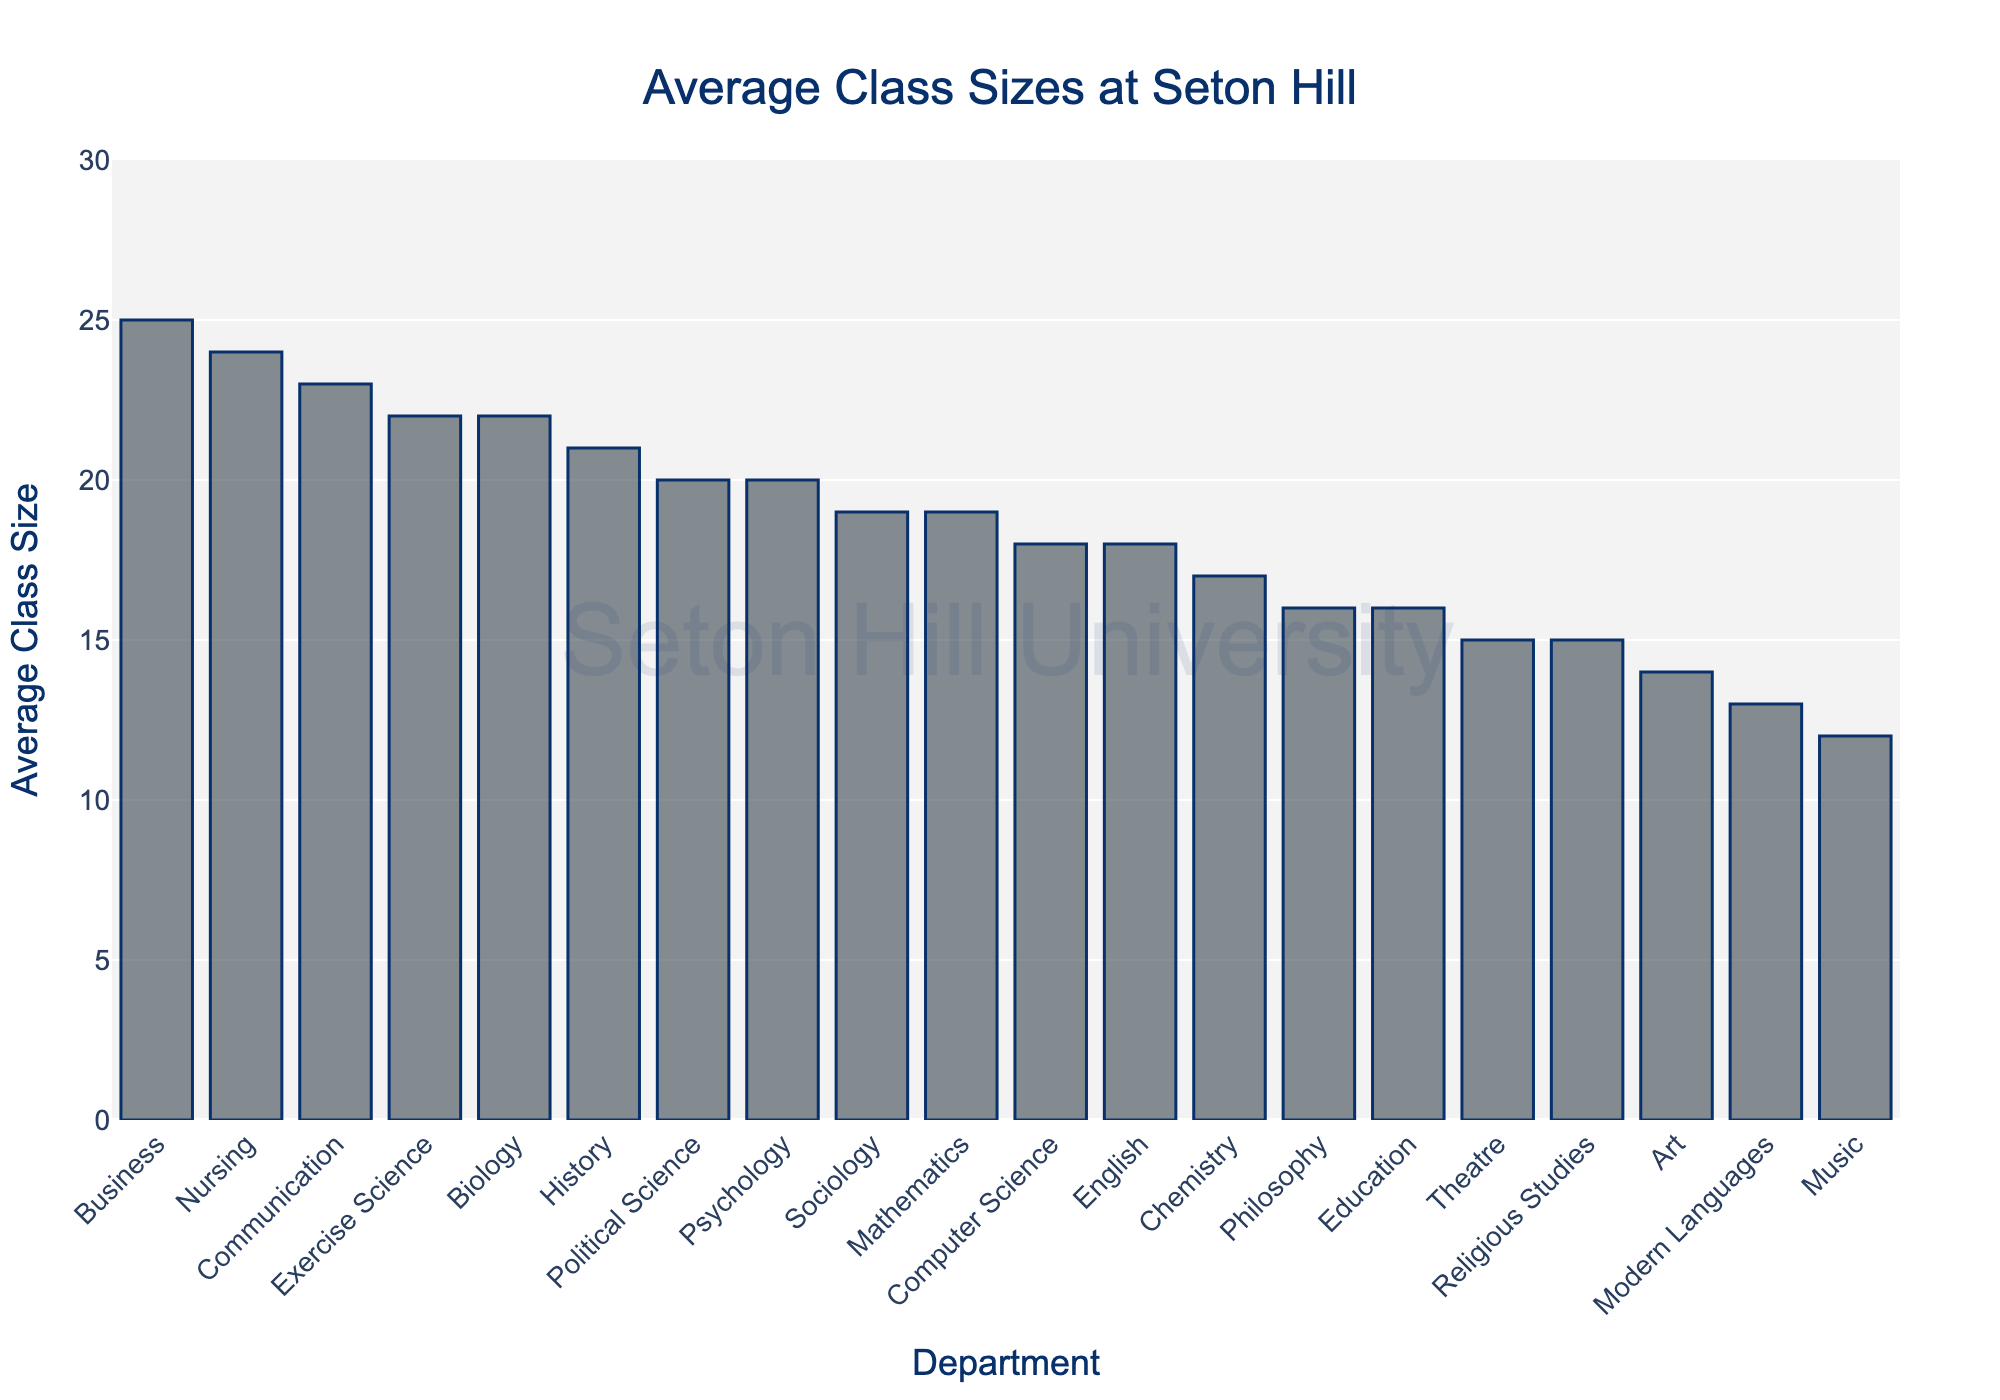Which department has the largest average class size? Visual inspection shows that the Business department has the highest bar, indicating the largest average class size of 25.
Answer: Business Which department has the smallest average class size? The Music department has the shortest bar, indicating the smallest average class size of 12.
Answer: Music What is the difference between the largest and smallest average class sizes? The largest average class size is in Business (25), and the smallest is in Music (12). Subtract 12 from 25 to find the difference: 25 - 12 = 13.
Answer: 13 Are there any departments with the same average class size? Yes, the Psychology and Political Science departments both have an average class size of 20.
Answer: Yes How does the average class size of the Education department compare to that of the Mathematics department? The Education department has an average class size of 16, while the Mathematics department has an average class size of 19, meaning Education's size is smaller.
Answer: Education smaller What is the combined average class size of the Art and Theatre departments? Art has an average class size of 14 and Theatre has 15. Adding these together: 14 + 15 = 29.
Answer: 29 Which department is ranked third in terms of average class size? By looking at the descending order of average class sizes, Communication is the third largest, with an average class size of 23.
Answer: Communication What is the mean average class size of all the departments combined? Sum the average class sizes and divide by the number of departments: (18+22+20+25+16+14+19+21+23+15+17+20+12+24+18+16+13+15+22+19)/20 = 396/20 = 19.8.
Answer: 19.8 Is the average class size in Computer Science greater than in English? The Computer Science department has an average class size of 18, the same as the English department, so it is not greater.
Answer: No 